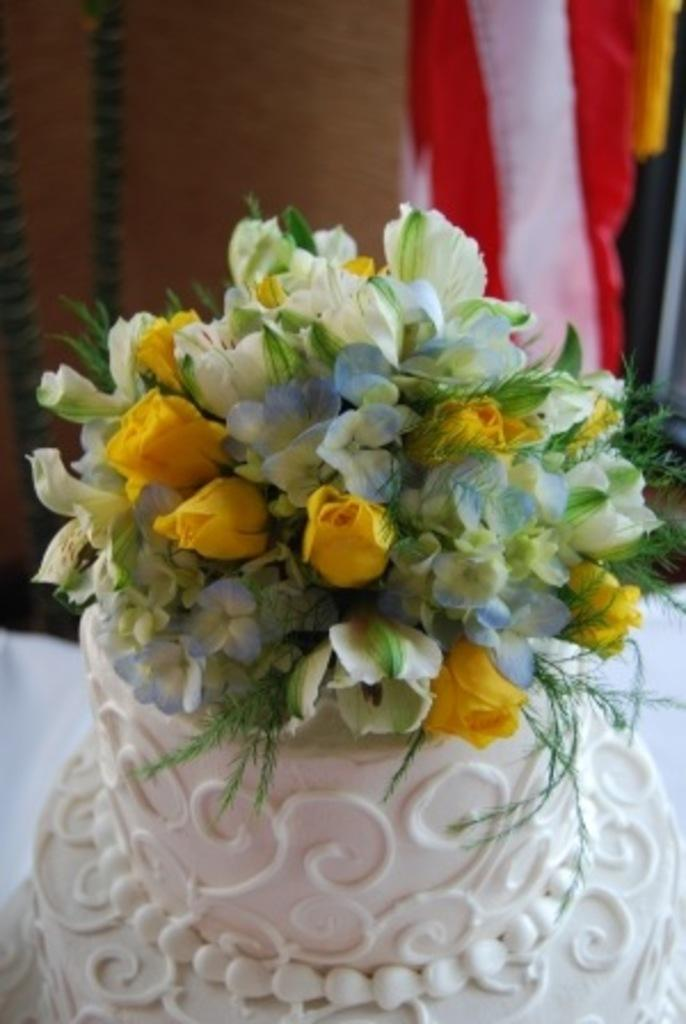What decorations can be seen on the cake in the image? There are flowers and leaves on the cake in the image. How would you describe the background of the image? The background of the image is blurry. What type of snails can be seen crawling on the cake in the image? There are no snails present on the cake in the image. 